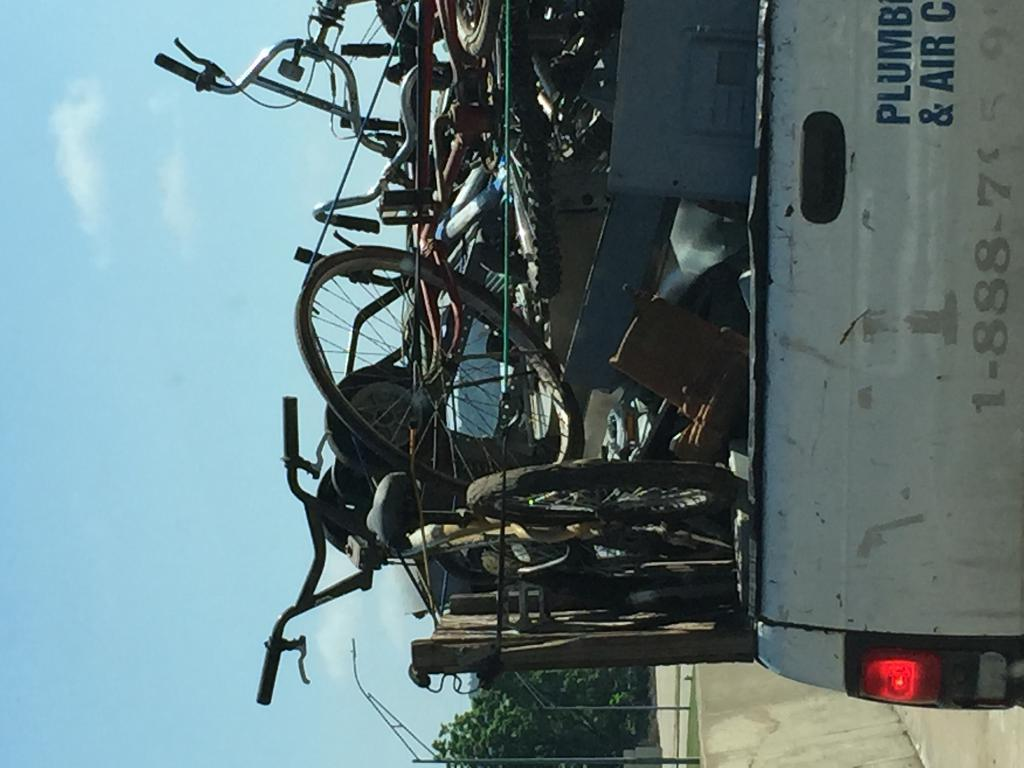What type of vehicles are present in the image? There are bicycles in the image. What can be seen inside the vehicle in the image? There are objects in a vehicle in the image. What is the background of the image made up of? There is a wall, grass, poles, a light, trees, and the sky visible in the image. What type of authority is depicted in the image? There is no authority figure present in the image. How many pizzas are visible in the image? There are no pizzas present in the image. 